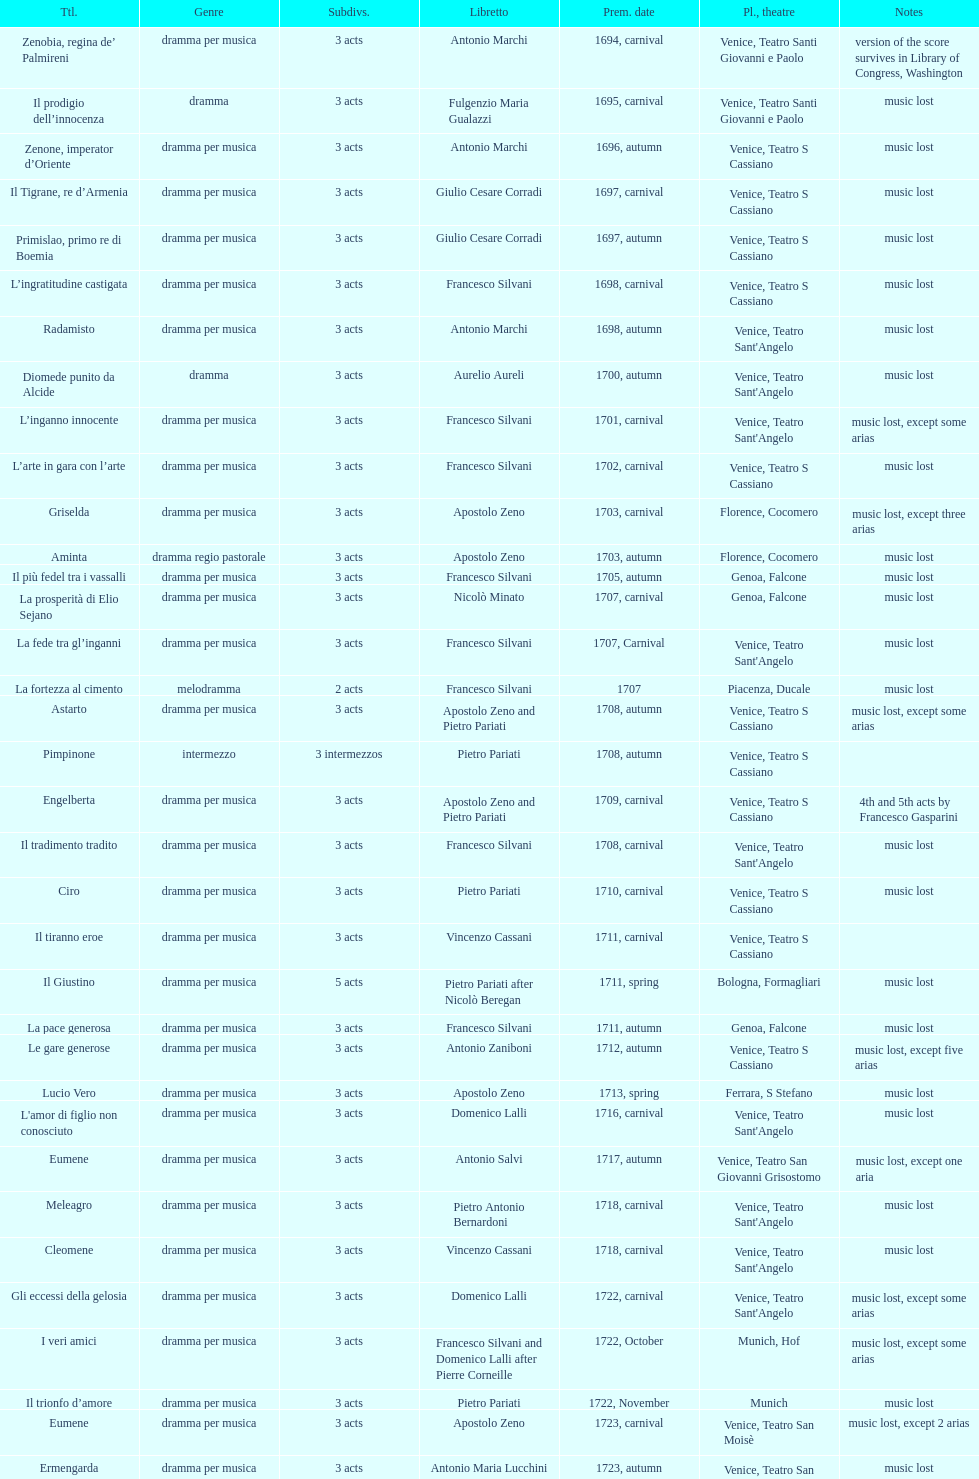Which was released earlier, artamene or merope? Merope. 